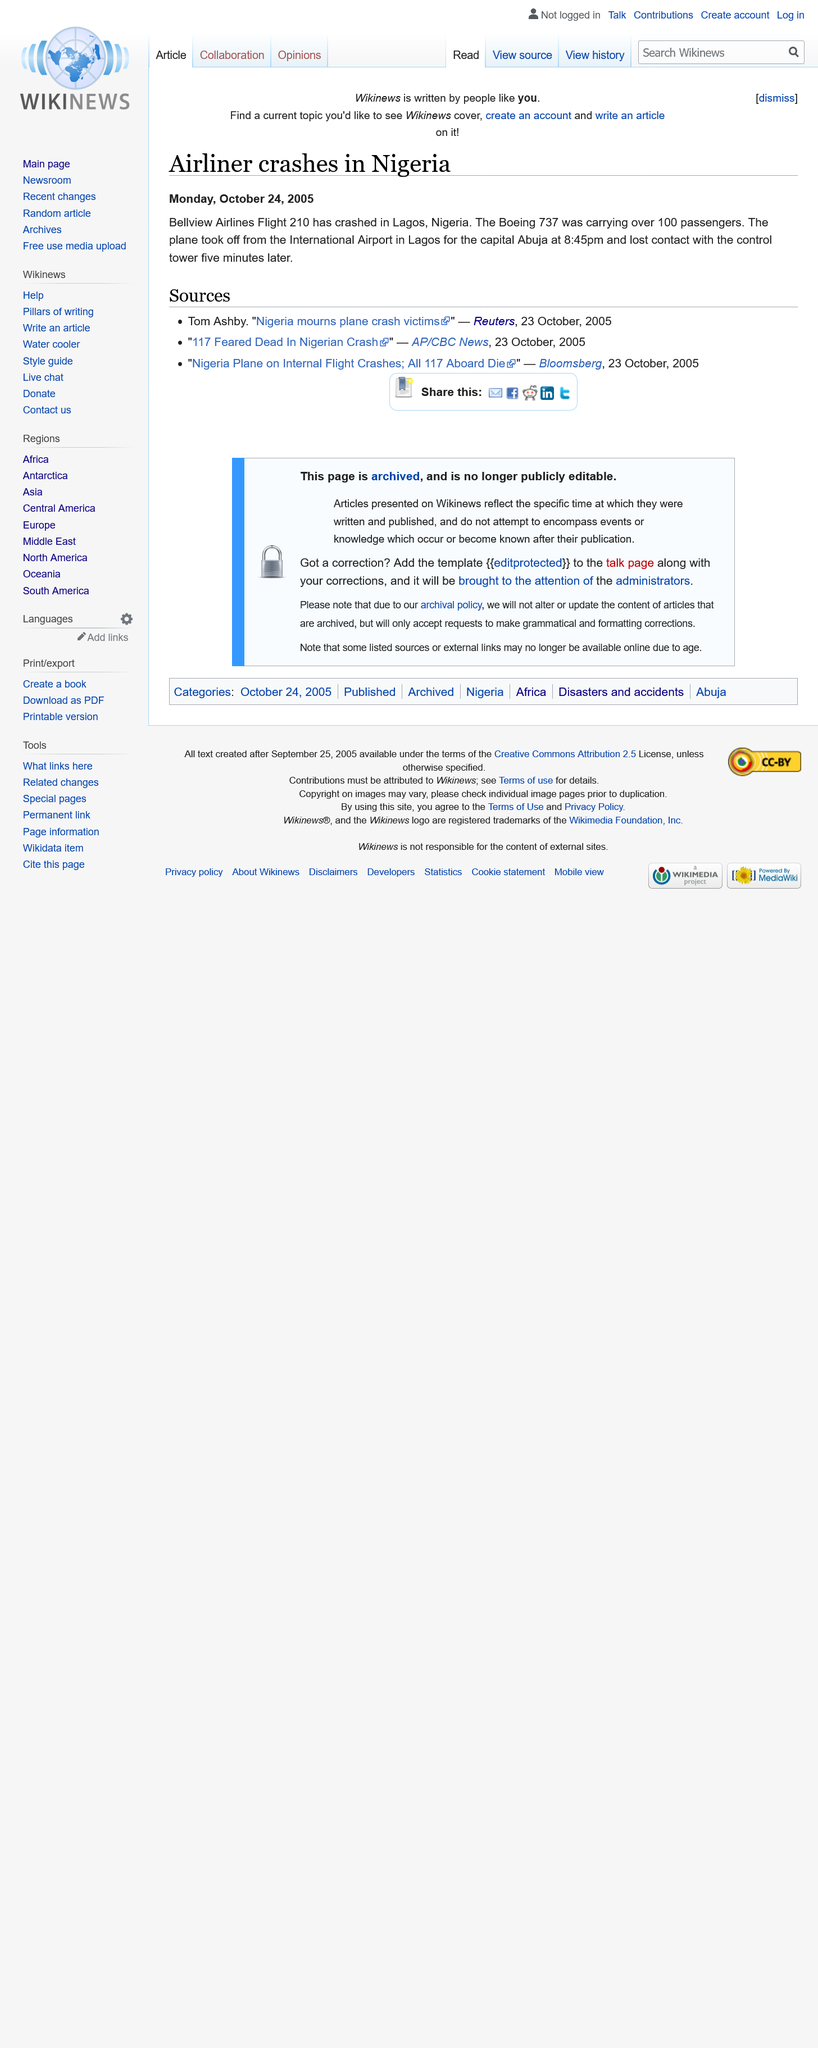Identify some key points in this picture. The flight took off at 8:45pm on a specific date. The aircraft was en route to Abuja. It is reported that 117 people are feared dead as a result of a plane crash that occurred in Lagos. 